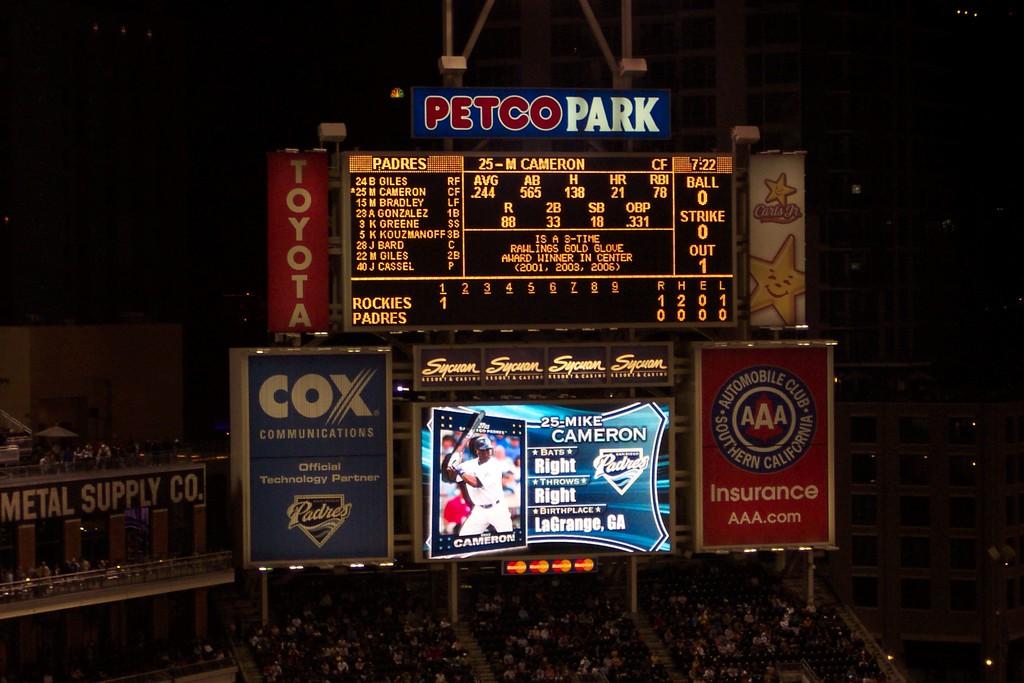What park is this at?
Ensure brevity in your answer.  Petco park. Who are some of the sponsors for this park?
Keep it short and to the point. Petco. 